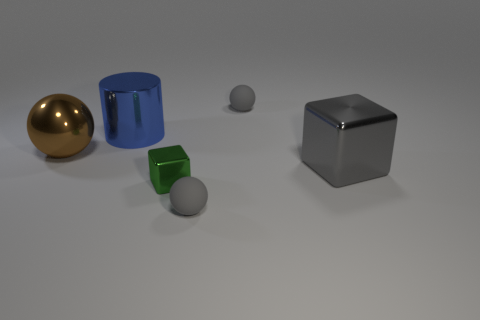Subtract all big brown spheres. How many spheres are left? 2 Add 2 red blocks. How many objects exist? 8 Subtract all brown spheres. How many spheres are left? 2 Add 4 large metal objects. How many large metal objects exist? 7 Subtract 0 red balls. How many objects are left? 6 Subtract all cubes. How many objects are left? 4 Subtract 1 balls. How many balls are left? 2 Subtract all green blocks. Subtract all blue cylinders. How many blocks are left? 1 Subtract all purple blocks. How many gray spheres are left? 2 Subtract all blue shiny cylinders. Subtract all tiny spheres. How many objects are left? 3 